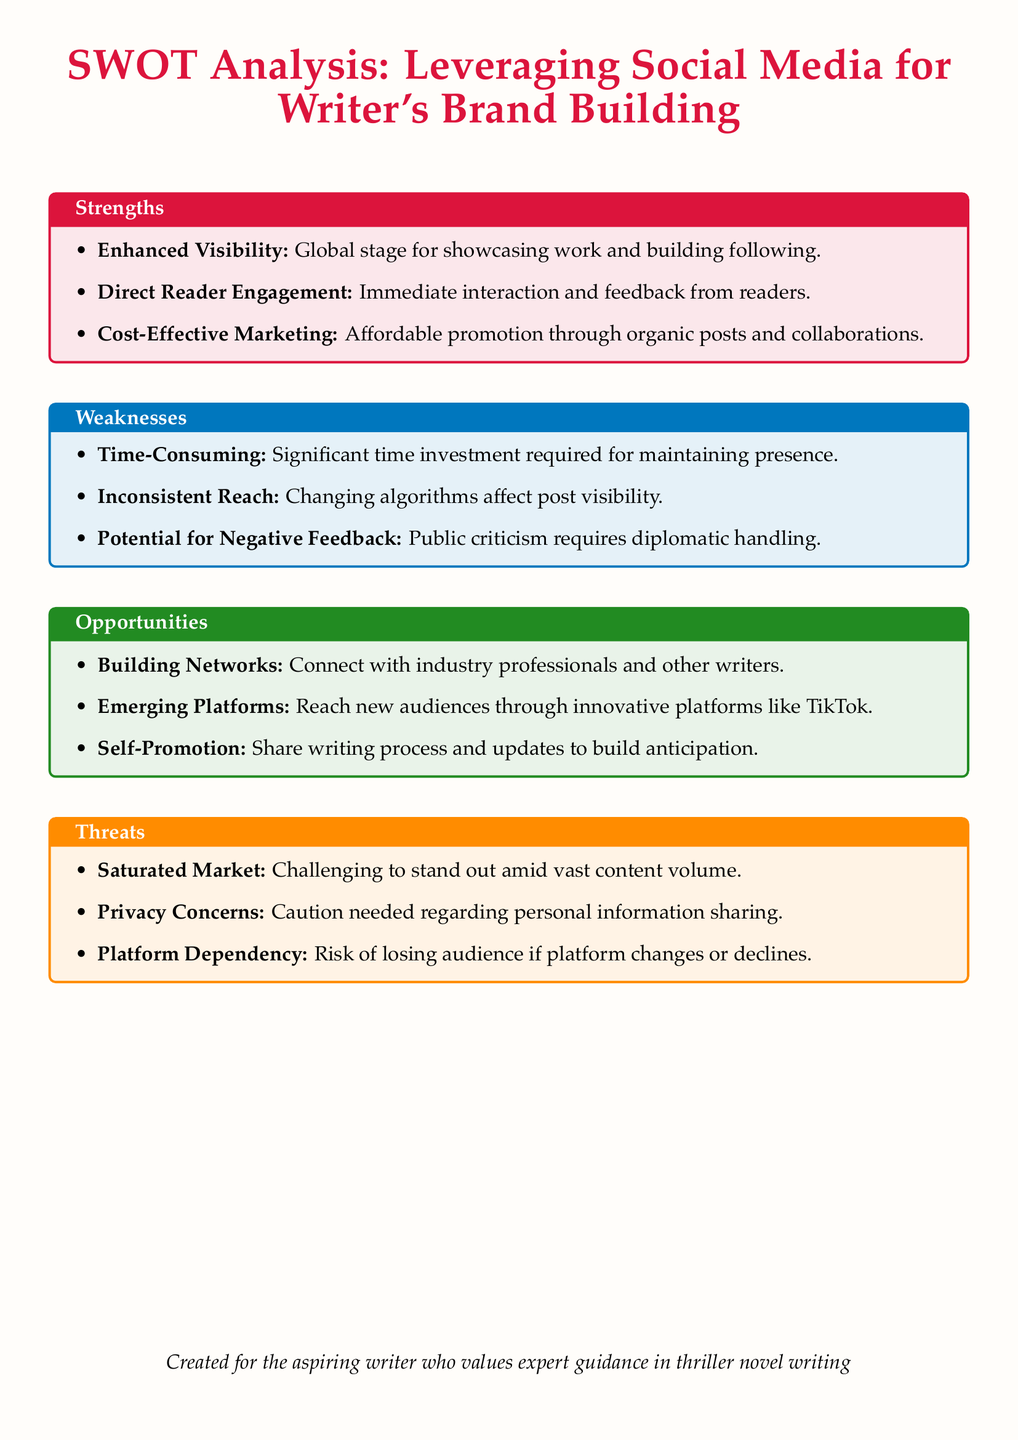What is the title of the document? The title is explicitly stated at the beginning of the document.
Answer: SWOT Analysis: Leveraging Social Media for Writer's Brand Building How many strengths are listed in the document? The number of strengths is mentioned in the section detailing strengths.
Answer: 3 What color is used for the weaknesses section? The document specifies a color associated with each section, indicating that it is blue.
Answer: Blue What is one opportunity mentioned in the document? An example from the opportunities section is needed for awareness of networking.
Answer: Building Networks How many threats are outlined in the document? The document lists the threats in a specified section that can be counted.
Answer: 3 What is a potential weakness of leveraging social media? Reference is made to specific personal experiences with social media challenges mentioned in the weaknesses.
Answer: Time-Consuming Which platform is mentioned as an emerging opportunity? The document specifies new platforms that can be utilized, highlighting one in particular.
Answer: TikTok What is a strength of using social media for brand building? The strengths section provides details on the advantages of social media presence.
Answer: Enhanced Visibility What risk is associated with platform dependency? The document refers to a potential consequence of relying solely on social media platforms.
Answer: Losing audience 